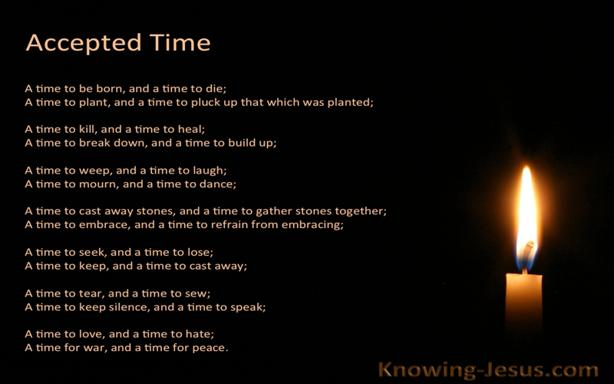What is the source website for the quote in the image? The quote displayed in the image originates from the Christian website, KnowingJesus.com. This site provides biblical insights and devotional materials that explore the meanings and applications of scripture in everyday life, making it a fitting source for such a profound and reflective quote. 